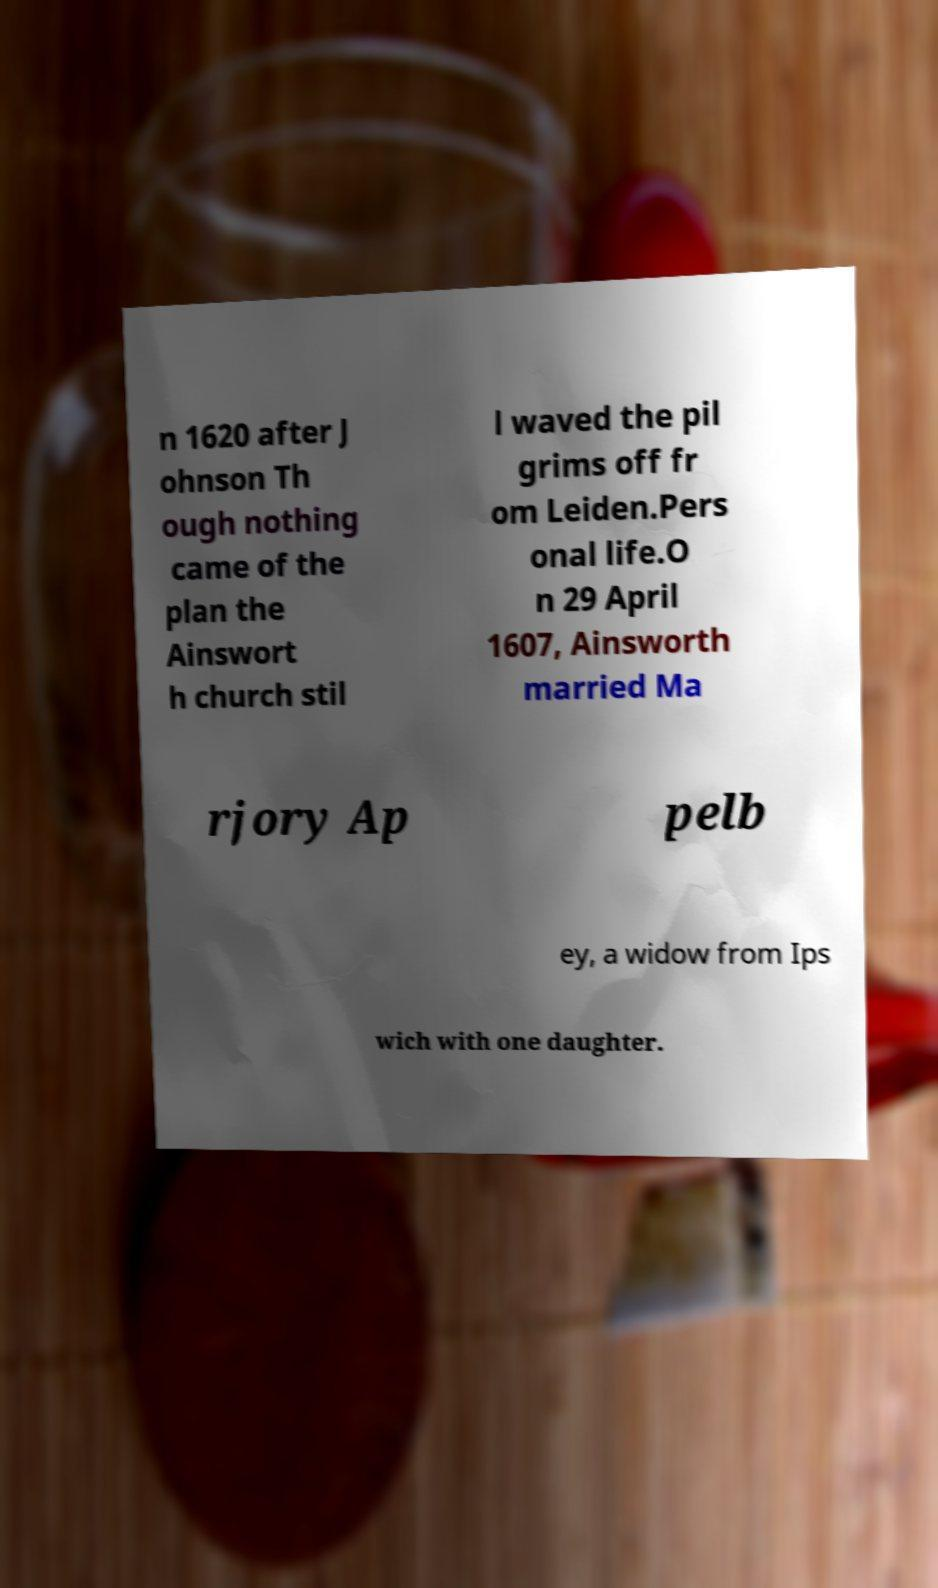Could you assist in decoding the text presented in this image and type it out clearly? n 1620 after J ohnson Th ough nothing came of the plan the Ainswort h church stil l waved the pil grims off fr om Leiden.Pers onal life.O n 29 April 1607, Ainsworth married Ma rjory Ap pelb ey, a widow from Ips wich with one daughter. 